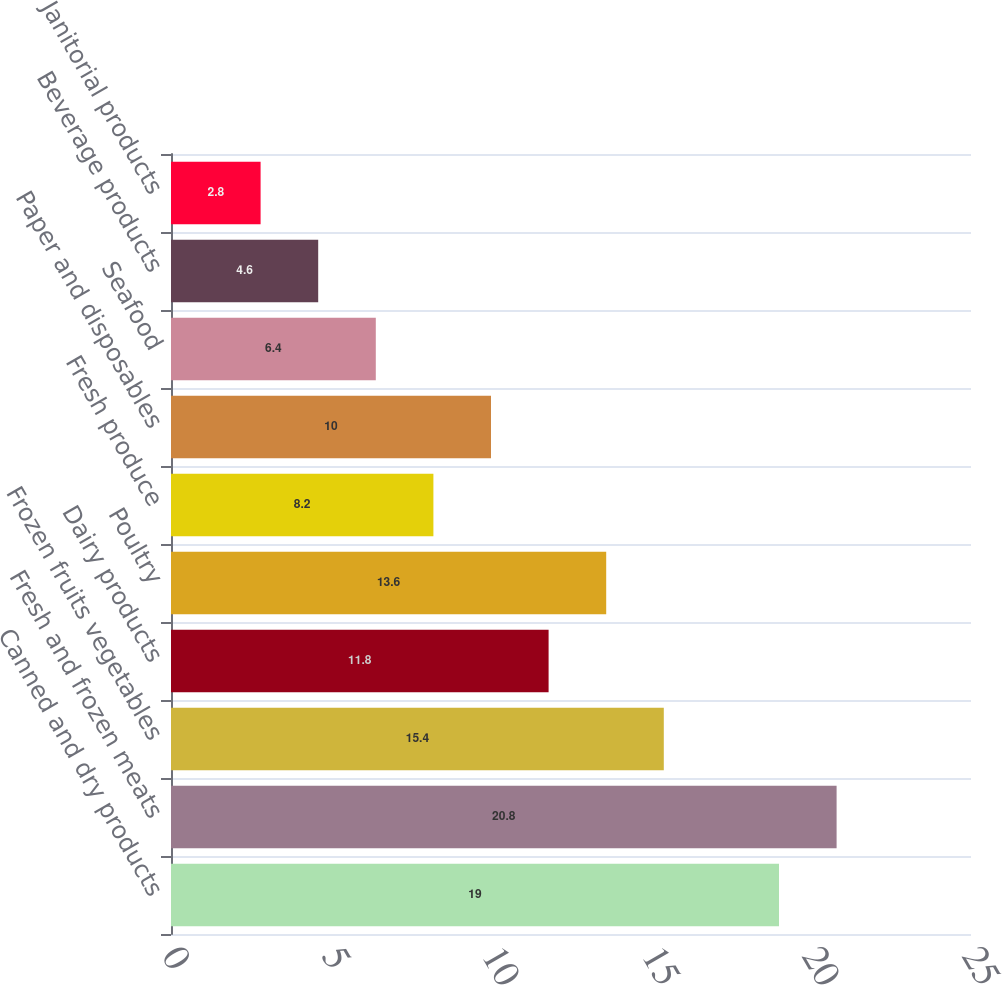Convert chart. <chart><loc_0><loc_0><loc_500><loc_500><bar_chart><fcel>Canned and dry products<fcel>Fresh and frozen meats<fcel>Frozen fruits vegetables<fcel>Dairy products<fcel>Poultry<fcel>Fresh produce<fcel>Paper and disposables<fcel>Seafood<fcel>Beverage products<fcel>Janitorial products<nl><fcel>19<fcel>20.8<fcel>15.4<fcel>11.8<fcel>13.6<fcel>8.2<fcel>10<fcel>6.4<fcel>4.6<fcel>2.8<nl></chart> 